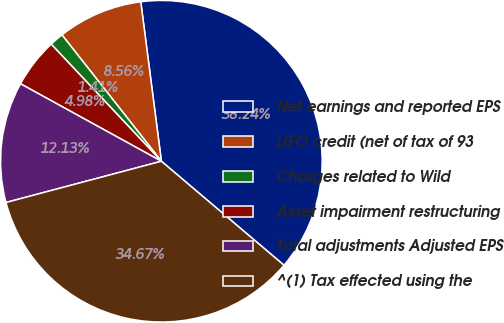<chart> <loc_0><loc_0><loc_500><loc_500><pie_chart><fcel>Net earnings and reported EPS<fcel>LIFO credit (net of tax of 93<fcel>Charges related to Wild<fcel>Asset impairment restructuring<fcel>Total adjustments Adjusted EPS<fcel>^(1) Tax effected using the<nl><fcel>38.24%<fcel>8.56%<fcel>1.41%<fcel>4.98%<fcel>12.13%<fcel>34.67%<nl></chart> 